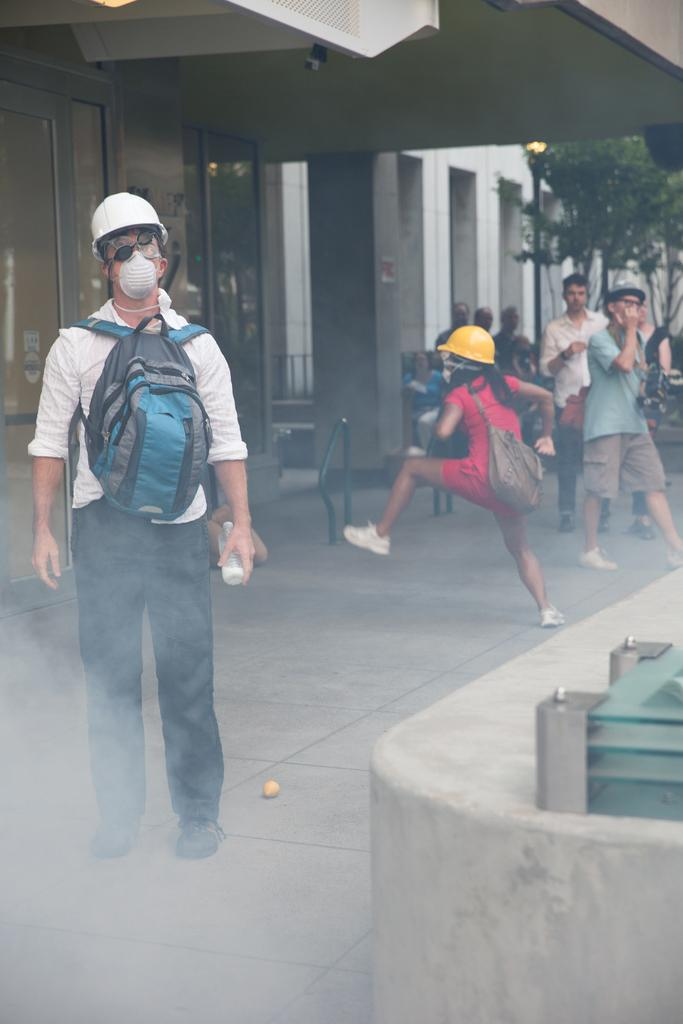What is the main subject of the image? There is a person standing in the image. What is the person wearing that is visible in the image? The person is wearing a bag. What can be seen in the background of the image? There is a group of people, trees, and a building in the background of the image. What type of cushion can be seen on the person's shoes in the image? There is no cushion or mention of shoes present in the image. 